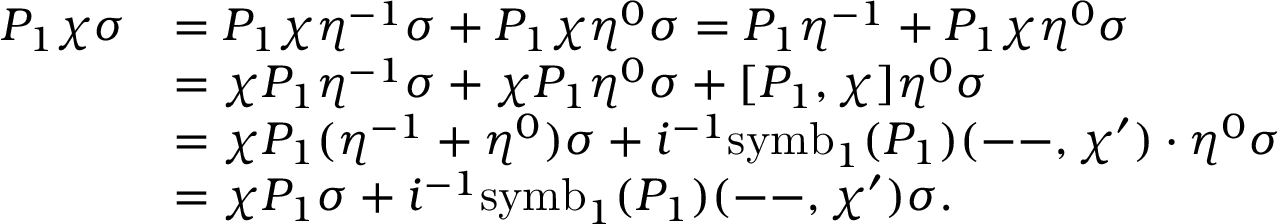Convert formula to latex. <formula><loc_0><loc_0><loc_500><loc_500>\begin{array} { r l } { P _ { 1 } \chi \sigma } & { = P _ { 1 } \chi \eta ^ { - 1 } \sigma + P _ { 1 } \chi \eta ^ { 0 } \sigma = P _ { 1 } \eta ^ { - 1 } + P _ { 1 } \chi \eta ^ { 0 } \sigma } \\ & { = \chi P _ { 1 } \eta ^ { - 1 } \sigma + \chi P _ { 1 } \eta ^ { 0 } \sigma + [ P _ { 1 } , \chi ] \eta ^ { 0 } \sigma } \\ & { = \chi P _ { 1 } ( \eta ^ { - 1 } + \eta ^ { 0 } ) \sigma + i ^ { - 1 } s y m b _ { 1 } ( P _ { 1 } ) ( - - , \chi ^ { \prime } ) \cdot \eta ^ { 0 } \sigma } \\ & { = \chi P _ { 1 } \sigma + i ^ { - 1 } s y m b _ { 1 } ( P _ { 1 } ) ( - - , \chi ^ { \prime } ) \sigma . } \end{array}</formula> 